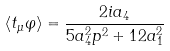<formula> <loc_0><loc_0><loc_500><loc_500>\left \langle t _ { \mu } \varphi \right \rangle = \frac { 2 i a _ { 4 } } { 5 a _ { 4 } ^ { 2 } p ^ { 2 } + 1 2 a _ { 1 } ^ { 2 } }</formula> 